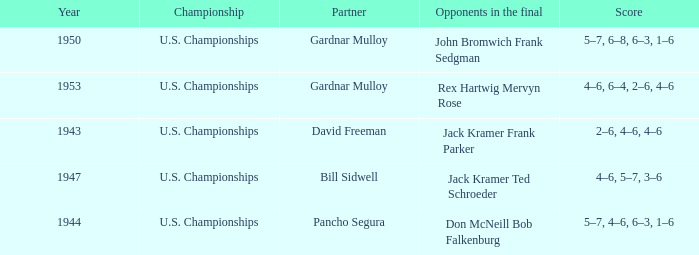Which Championship has a Score of 2–6, 4–6, 4–6? U.S. Championships. 